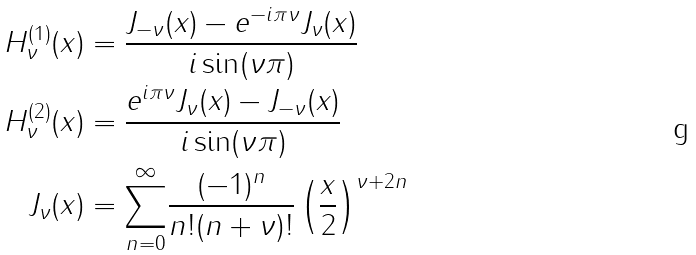<formula> <loc_0><loc_0><loc_500><loc_500>H _ { \nu } ^ { ( 1 ) } ( x ) & = \frac { J _ { - \nu } ( x ) - e ^ { - i \pi \nu } J _ { \nu } ( x ) } { i \sin ( \nu \pi ) } \\ H _ { \nu } ^ { ( 2 ) } ( x ) & = \frac { e ^ { i \pi \nu } J _ { \nu } ( x ) - J _ { - \nu } ( x ) } { i \sin ( \nu \pi ) } \\ J _ { \nu } ( x ) & = \overset { \infty } { \sum _ { \substack { n = 0 } } } \frac { ( - 1 ) ^ { n } } { n ! ( n + \nu ) ! } \left ( \frac { x } { 2 } \right ) ^ { \nu + 2 n }</formula> 